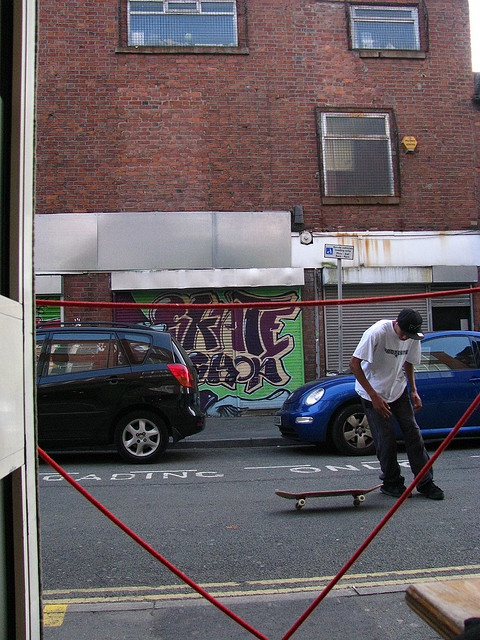Describe the objects in this image and their specific colors. I can see car in black, gray, darkblue, and navy tones, car in black, navy, and gray tones, people in black, gray, and maroon tones, and skateboard in black, gray, and maroon tones in this image. 